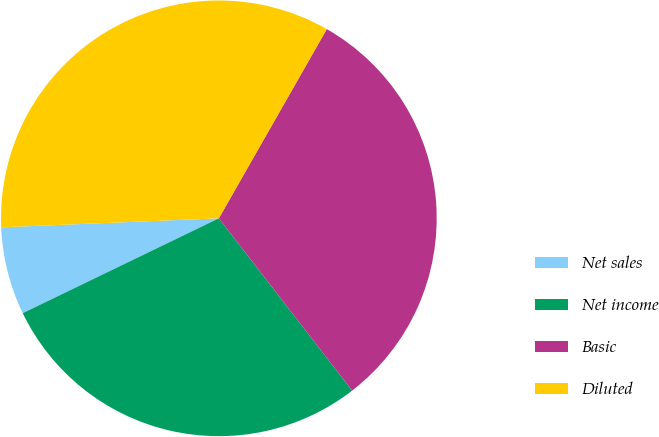<chart> <loc_0><loc_0><loc_500><loc_500><pie_chart><fcel>Net sales<fcel>Net income<fcel>Basic<fcel>Diluted<nl><fcel>6.51%<fcel>28.31%<fcel>31.27%<fcel>33.91%<nl></chart> 